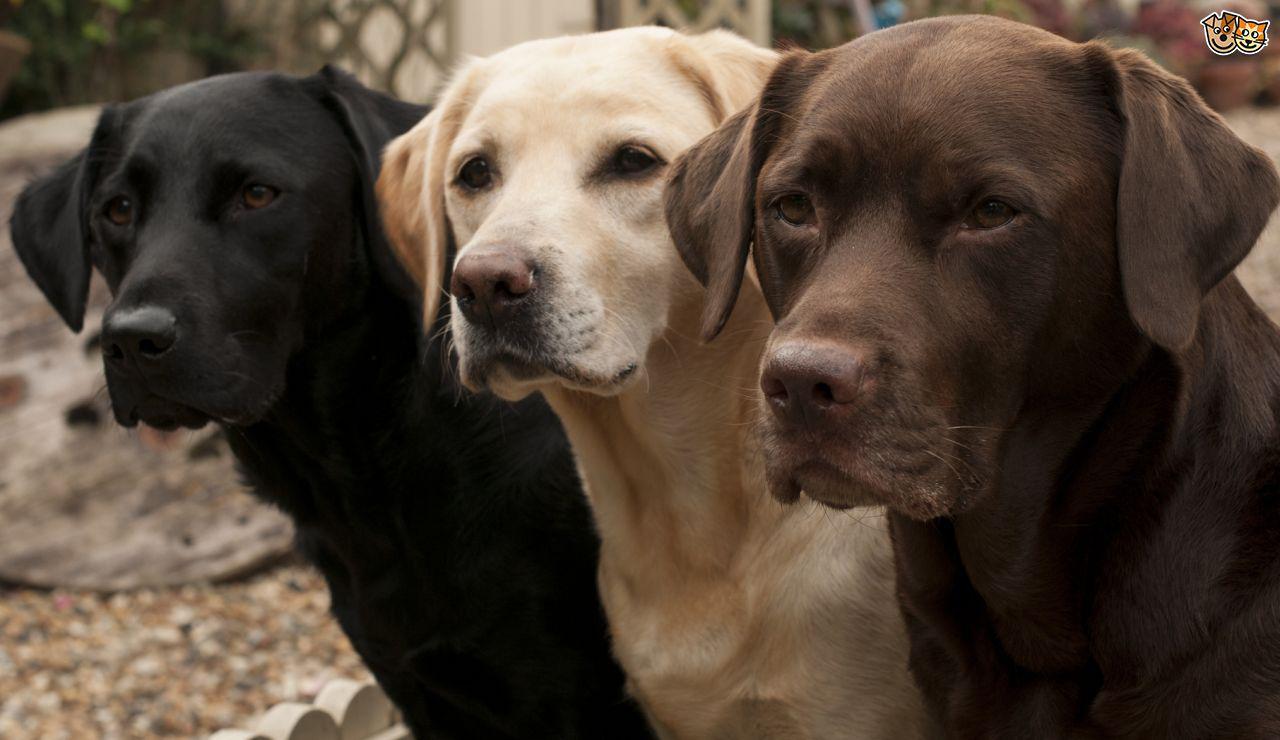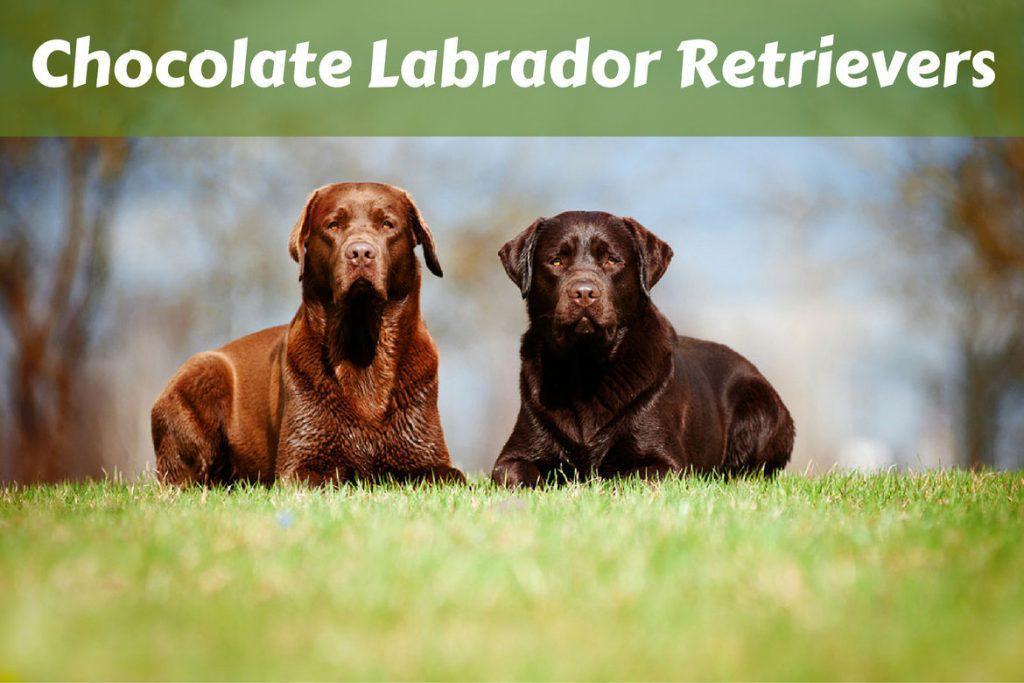The first image is the image on the left, the second image is the image on the right. Analyze the images presented: Is the assertion "Each image shows at least three labrador retriever dogs sitting upright in a horizontal row." valid? Answer yes or no. No. 